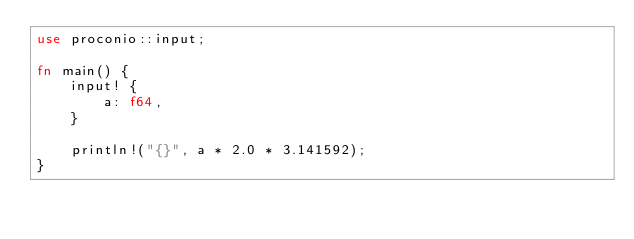<code> <loc_0><loc_0><loc_500><loc_500><_Rust_>use proconio::input;

fn main() {
    input! {
        a: f64,
    }

    println!("{}", a * 2.0 * 3.141592);
}
</code> 